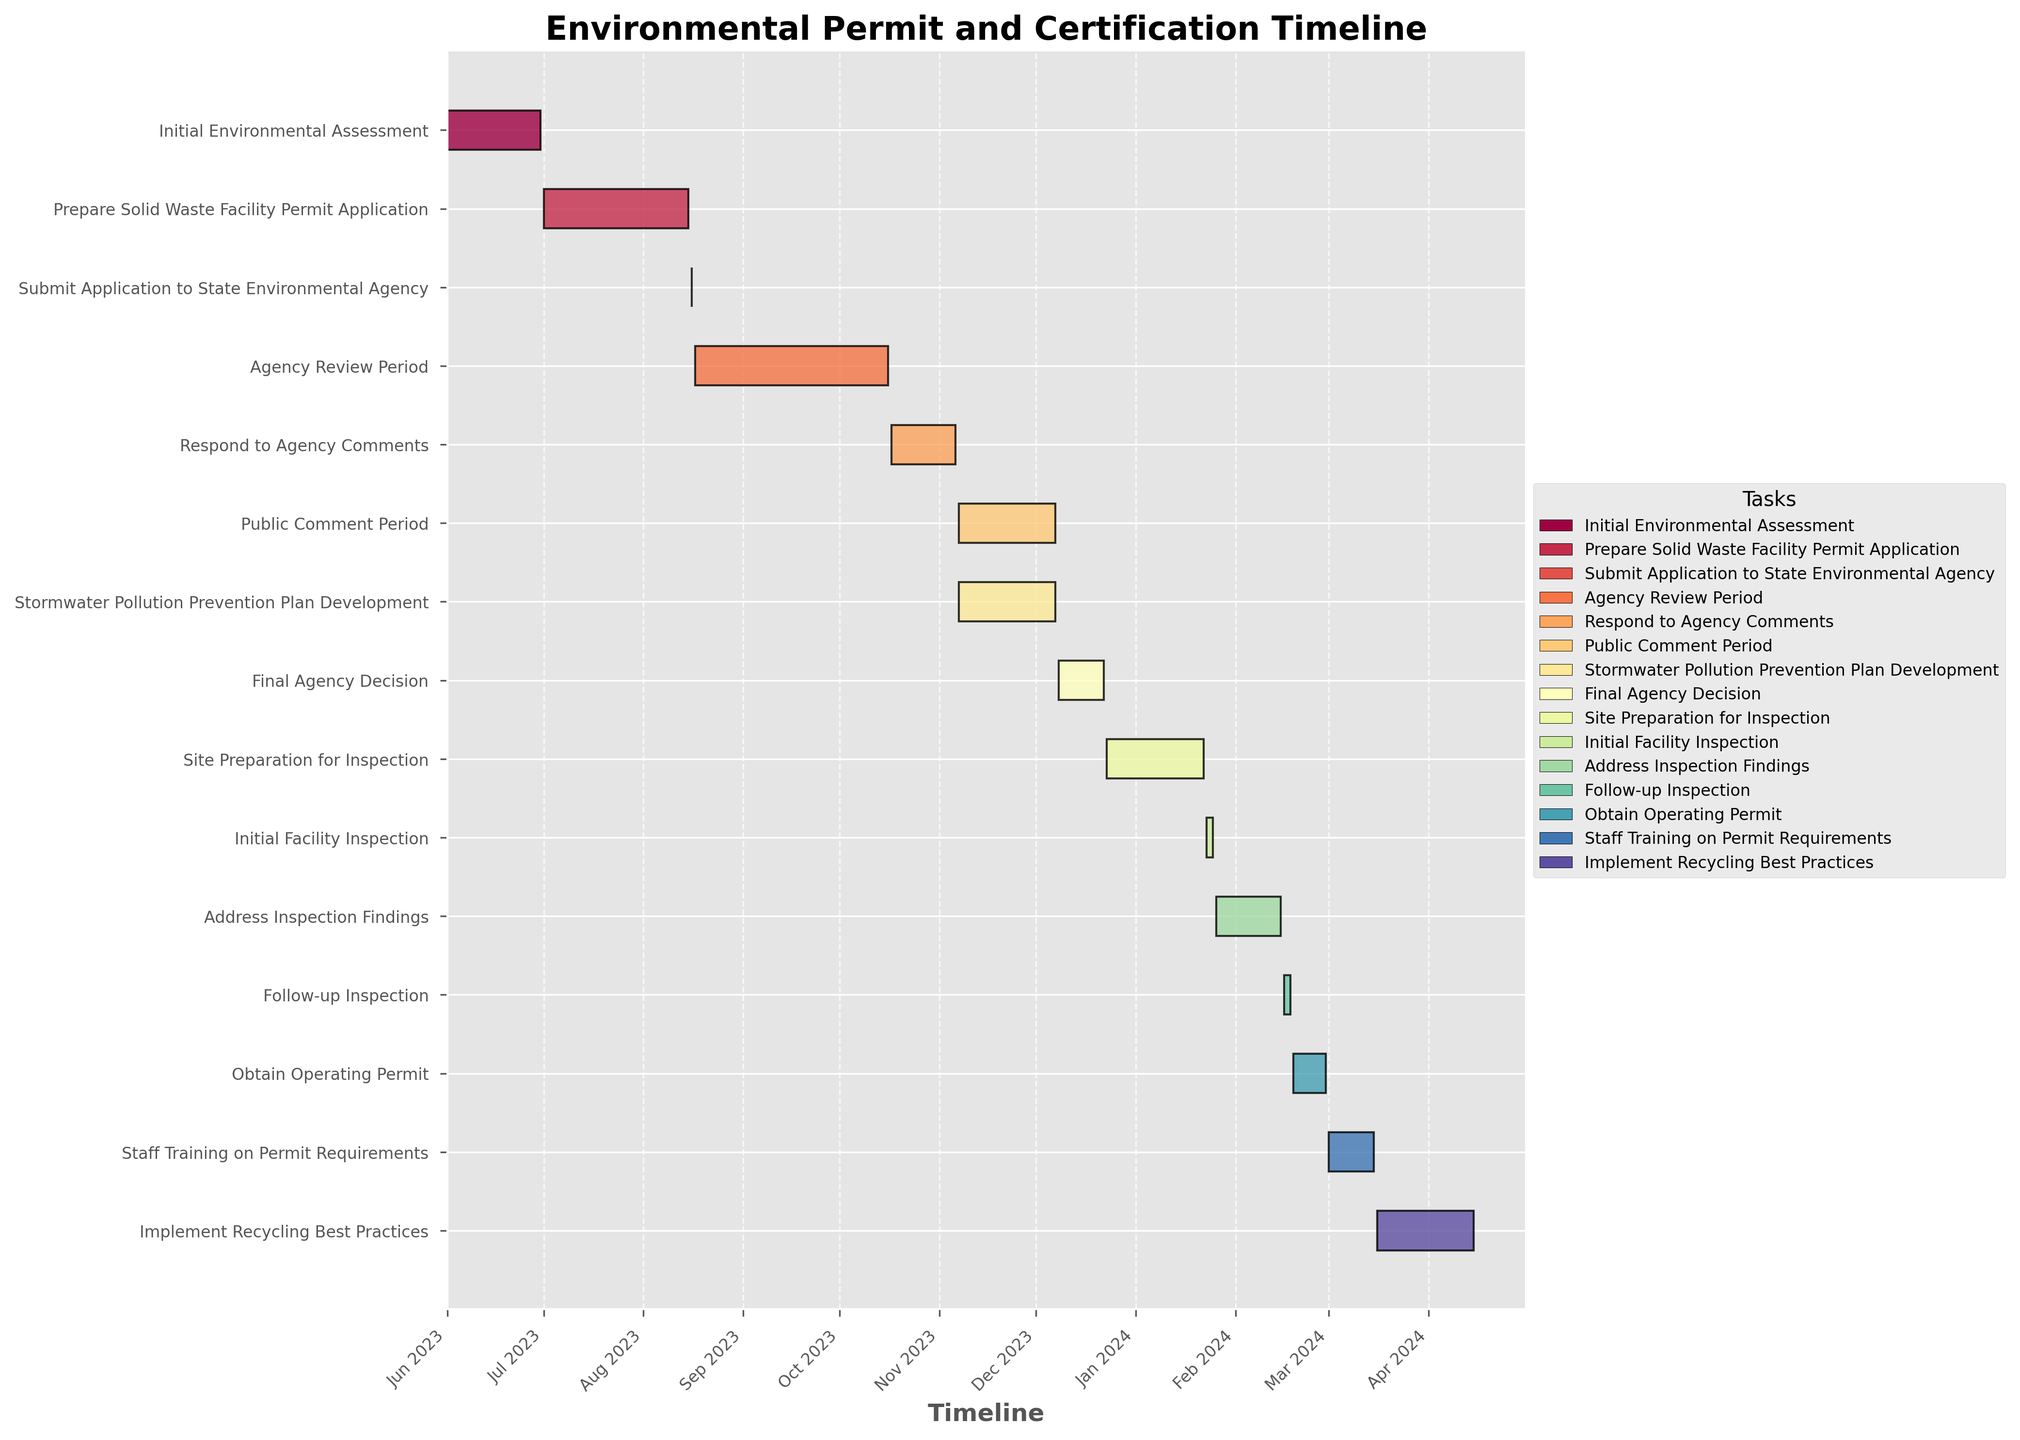How long did the 'Initial Environmental Assessment' take? To check the duration of the 'Initial Environmental Assessment', look at the start and end dates. It starts on June 1, 2023, and ends on June 30, 2023, covering a period of 30 days.
Answer: 30 days What is the title of the Gantt chart? The title can be found at the top of the chart. It is 'Environmental Permit and Certification Timeline'.
Answer: Environmental Permit and Certification Timeline Which task spans from August 17, 2023, to October 16, 2023? By examining the timeline of the tasks, we see that the 'Agency Review Period' is the task that covers the period from August 17, 2023, to October 16, 2023.
Answer: Agency Review Period How many tasks occur in November 2023? By looking at the tasks and their corresponding dates, we see that 'Public Comment Period' and 'Stormwater Pollution Prevention Plan Development' both occur in November 2023.
Answer: 2 tasks Which tasks overlap with the 'Final Agency Decision' period? For overlapping tasks, compare the dates. 'Final Agency Decision' is from December 8, 2023, to December 22, 2023. The overlapping tasks are 'Public Comment Period' and 'Stormwater Pollution Prevention Plan Development'.
Answer: Public Comment Period, Stormwater Pollution Prevention Plan Development Which task has the shortest duration? Checking the start and end dates of all tasks, 'Submit Application to State Environmental Agency' takes just one day, making it the shortest.
Answer: Submit Application to State Environmental Agency How long did it take from the start of 'Initial Facility Inspection' to the end of 'Follow-up Inspection'? Find the start date of 'Initial Facility Inspection' and the end date of 'Follow-up Inspection'. The start is January 23, 2024, and the end is February 18, 2024. The total duration is 27 days.
Answer: 27 days When does 'Staff Training on Permit Requirements' end? Examine the dates for 'Staff Training on Permit Requirements'. It starts on March 1, 2024, and ends on March 15, 2024.
Answer: March 15, 2024 Which task directly precedes 'Implement Recycling Best Practices'? The task that ends just before 'Implement Recycling Best Practices' starts is 'Staff Training on Permit Requirements'.
Answer: Staff Training on Permit Requirements 